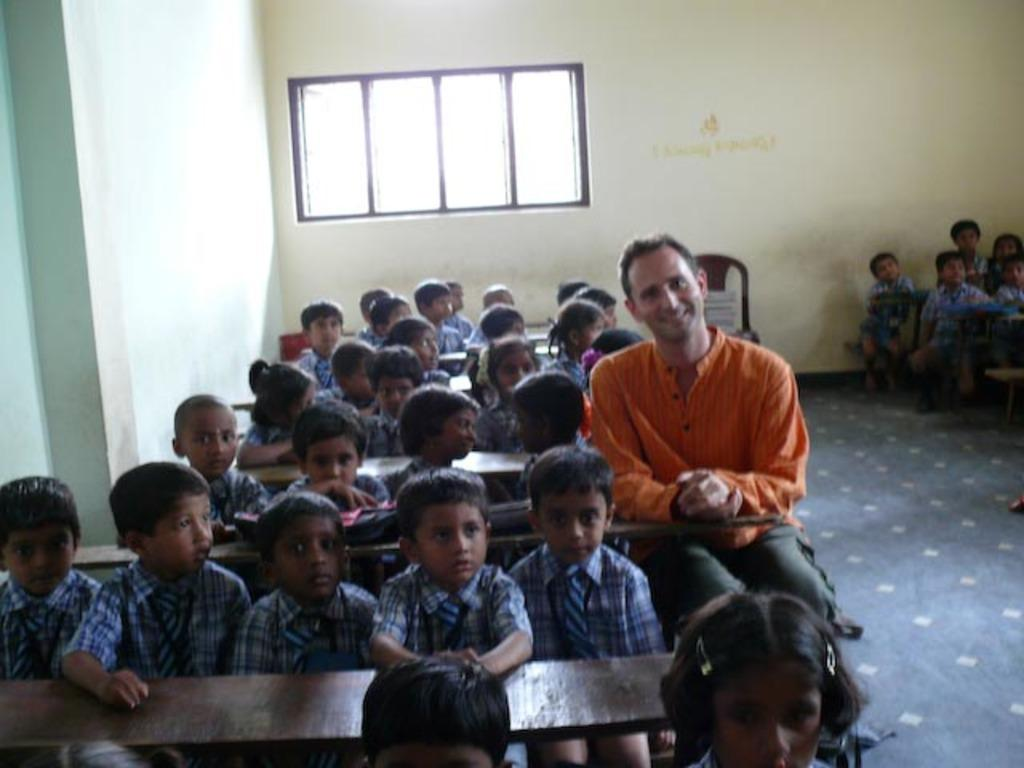What are the kids doing in the image? The kids are sitting on a bench in the image. Who else is sitting in the image? There is a man sitting in the image, and there are other people sitting at the right side in the image. What can be seen in the background of the image? There is a window visible in the background of the image. What type of fiction is the man reading in the image? There is no book or any indication of reading in the image, so it cannot be determined if the man is reading fiction or any other type of material. 